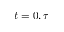<formula> <loc_0><loc_0><loc_500><loc_500>t = 0 , \tau</formula> 